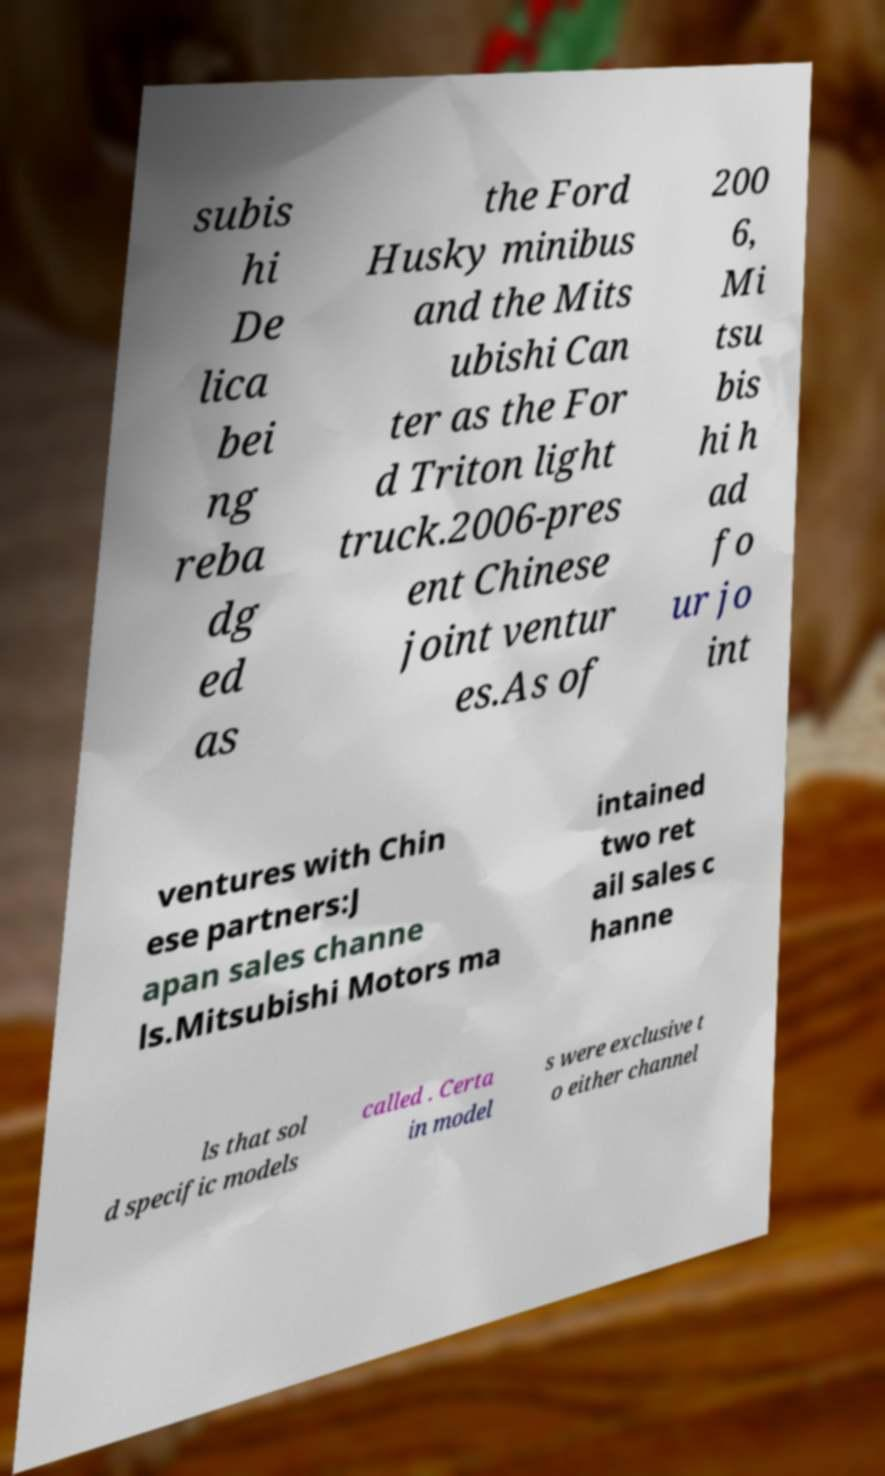Can you read and provide the text displayed in the image?This photo seems to have some interesting text. Can you extract and type it out for me? subis hi De lica bei ng reba dg ed as the Ford Husky minibus and the Mits ubishi Can ter as the For d Triton light truck.2006-pres ent Chinese joint ventur es.As of 200 6, Mi tsu bis hi h ad fo ur jo int ventures with Chin ese partners:J apan sales channe ls.Mitsubishi Motors ma intained two ret ail sales c hanne ls that sol d specific models called . Certa in model s were exclusive t o either channel 